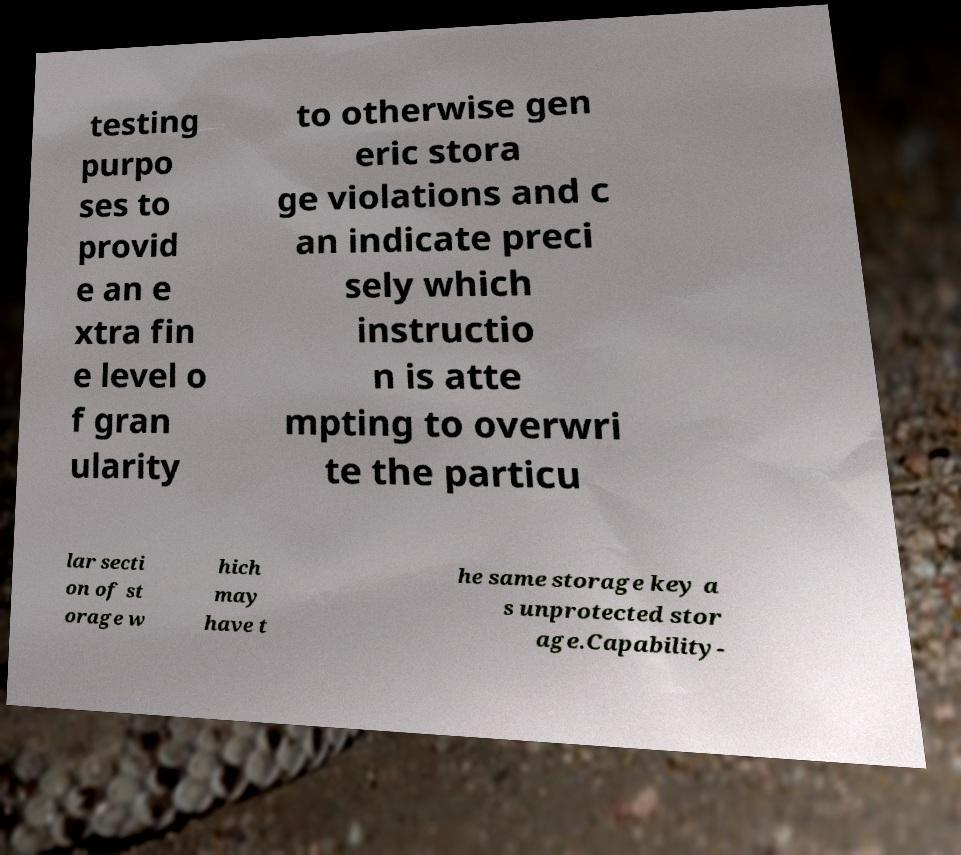Can you read and provide the text displayed in the image?This photo seems to have some interesting text. Can you extract and type it out for me? testing purpo ses to provid e an e xtra fin e level o f gran ularity to otherwise gen eric stora ge violations and c an indicate preci sely which instructio n is atte mpting to overwri te the particu lar secti on of st orage w hich may have t he same storage key a s unprotected stor age.Capability- 